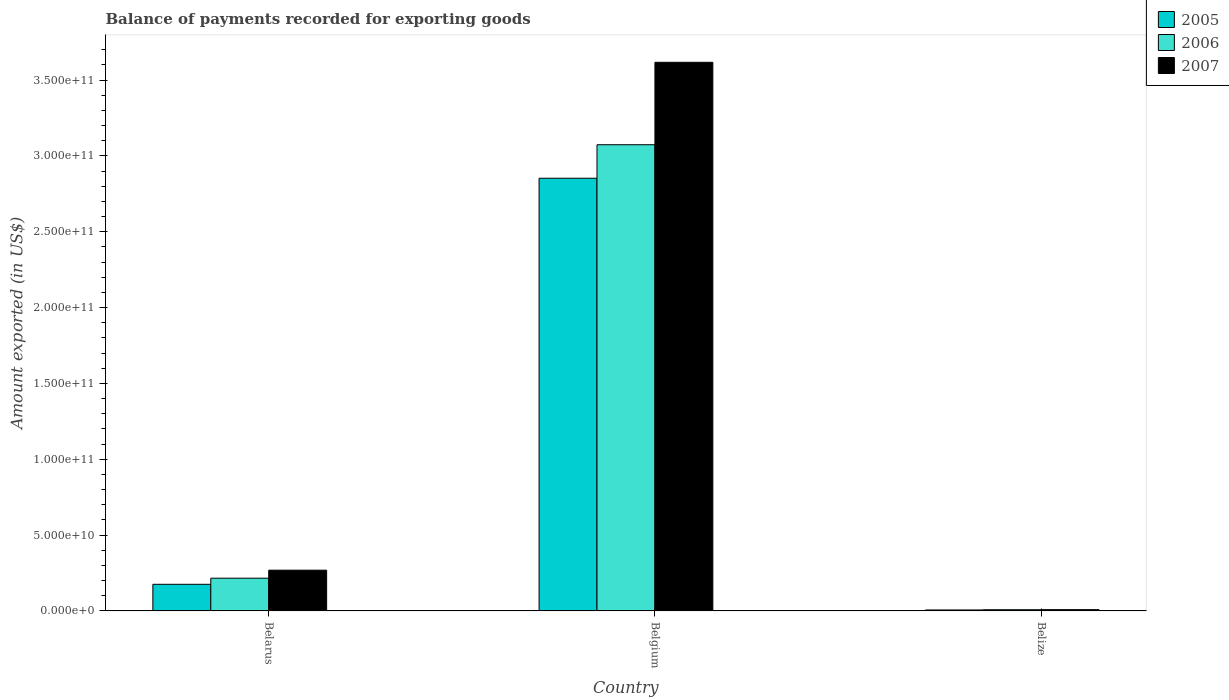How many different coloured bars are there?
Make the answer very short. 3. How many groups of bars are there?
Provide a short and direct response. 3. Are the number of bars on each tick of the X-axis equal?
Your response must be concise. Yes. What is the label of the 1st group of bars from the left?
Keep it short and to the point. Belarus. In how many cases, is the number of bars for a given country not equal to the number of legend labels?
Offer a terse response. 0. What is the amount exported in 2007 in Belgium?
Your response must be concise. 3.62e+11. Across all countries, what is the maximum amount exported in 2007?
Your answer should be very brief. 3.62e+11. Across all countries, what is the minimum amount exported in 2006?
Ensure brevity in your answer.  7.76e+08. In which country was the amount exported in 2007 minimum?
Provide a succinct answer. Belize. What is the total amount exported in 2006 in the graph?
Give a very brief answer. 3.30e+11. What is the difference between the amount exported in 2005 in Belarus and that in Belgium?
Your answer should be very brief. -2.68e+11. What is the difference between the amount exported in 2007 in Belgium and the amount exported in 2006 in Belarus?
Offer a very short reply. 3.40e+11. What is the average amount exported in 2005 per country?
Provide a succinct answer. 1.01e+11. What is the difference between the amount exported of/in 2006 and amount exported of/in 2007 in Belgium?
Make the answer very short. -5.44e+1. In how many countries, is the amount exported in 2007 greater than 180000000000 US$?
Ensure brevity in your answer.  1. What is the ratio of the amount exported in 2006 in Belarus to that in Belize?
Offer a very short reply. 27.8. What is the difference between the highest and the second highest amount exported in 2005?
Provide a succinct answer. 2.85e+11. What is the difference between the highest and the lowest amount exported in 2005?
Your response must be concise. 2.85e+11. What does the 1st bar from the left in Belize represents?
Your answer should be compact. 2005. What does the 3rd bar from the right in Belgium represents?
Your response must be concise. 2005. How many bars are there?
Keep it short and to the point. 9. Are all the bars in the graph horizontal?
Provide a short and direct response. No. What is the difference between two consecutive major ticks on the Y-axis?
Offer a very short reply. 5.00e+1. Does the graph contain grids?
Your response must be concise. No. Where does the legend appear in the graph?
Ensure brevity in your answer.  Top right. How are the legend labels stacked?
Your response must be concise. Vertical. What is the title of the graph?
Provide a succinct answer. Balance of payments recorded for exporting goods. What is the label or title of the X-axis?
Give a very brief answer. Country. What is the label or title of the Y-axis?
Offer a very short reply. Amount exported (in US$). What is the Amount exported (in US$) of 2005 in Belarus?
Your answer should be compact. 1.75e+1. What is the Amount exported (in US$) in 2006 in Belarus?
Offer a very short reply. 2.16e+1. What is the Amount exported (in US$) of 2007 in Belarus?
Keep it short and to the point. 2.69e+1. What is the Amount exported (in US$) in 2005 in Belgium?
Keep it short and to the point. 2.85e+11. What is the Amount exported (in US$) of 2006 in Belgium?
Offer a very short reply. 3.07e+11. What is the Amount exported (in US$) of 2007 in Belgium?
Offer a very short reply. 3.62e+11. What is the Amount exported (in US$) of 2005 in Belize?
Give a very brief answer. 6.15e+08. What is the Amount exported (in US$) in 2006 in Belize?
Your answer should be very brief. 7.76e+08. What is the Amount exported (in US$) of 2007 in Belize?
Keep it short and to the point. 8.16e+08. Across all countries, what is the maximum Amount exported (in US$) in 2005?
Offer a terse response. 2.85e+11. Across all countries, what is the maximum Amount exported (in US$) in 2006?
Ensure brevity in your answer.  3.07e+11. Across all countries, what is the maximum Amount exported (in US$) of 2007?
Your answer should be very brief. 3.62e+11. Across all countries, what is the minimum Amount exported (in US$) of 2005?
Make the answer very short. 6.15e+08. Across all countries, what is the minimum Amount exported (in US$) in 2006?
Provide a short and direct response. 7.76e+08. Across all countries, what is the minimum Amount exported (in US$) in 2007?
Your answer should be very brief. 8.16e+08. What is the total Amount exported (in US$) of 2005 in the graph?
Keep it short and to the point. 3.03e+11. What is the total Amount exported (in US$) of 2006 in the graph?
Give a very brief answer. 3.30e+11. What is the total Amount exported (in US$) in 2007 in the graph?
Your answer should be very brief. 3.89e+11. What is the difference between the Amount exported (in US$) in 2005 in Belarus and that in Belgium?
Your response must be concise. -2.68e+11. What is the difference between the Amount exported (in US$) of 2006 in Belarus and that in Belgium?
Your response must be concise. -2.86e+11. What is the difference between the Amount exported (in US$) of 2007 in Belarus and that in Belgium?
Make the answer very short. -3.35e+11. What is the difference between the Amount exported (in US$) in 2005 in Belarus and that in Belize?
Your response must be concise. 1.69e+1. What is the difference between the Amount exported (in US$) of 2006 in Belarus and that in Belize?
Your answer should be compact. 2.08e+1. What is the difference between the Amount exported (in US$) of 2007 in Belarus and that in Belize?
Offer a very short reply. 2.60e+1. What is the difference between the Amount exported (in US$) in 2005 in Belgium and that in Belize?
Offer a terse response. 2.85e+11. What is the difference between the Amount exported (in US$) of 2006 in Belgium and that in Belize?
Offer a terse response. 3.07e+11. What is the difference between the Amount exported (in US$) in 2007 in Belgium and that in Belize?
Make the answer very short. 3.61e+11. What is the difference between the Amount exported (in US$) of 2005 in Belarus and the Amount exported (in US$) of 2006 in Belgium?
Offer a very short reply. -2.90e+11. What is the difference between the Amount exported (in US$) in 2005 in Belarus and the Amount exported (in US$) in 2007 in Belgium?
Offer a terse response. -3.44e+11. What is the difference between the Amount exported (in US$) in 2006 in Belarus and the Amount exported (in US$) in 2007 in Belgium?
Ensure brevity in your answer.  -3.40e+11. What is the difference between the Amount exported (in US$) in 2005 in Belarus and the Amount exported (in US$) in 2006 in Belize?
Your response must be concise. 1.68e+1. What is the difference between the Amount exported (in US$) in 2005 in Belarus and the Amount exported (in US$) in 2007 in Belize?
Give a very brief answer. 1.67e+1. What is the difference between the Amount exported (in US$) of 2006 in Belarus and the Amount exported (in US$) of 2007 in Belize?
Give a very brief answer. 2.08e+1. What is the difference between the Amount exported (in US$) in 2005 in Belgium and the Amount exported (in US$) in 2006 in Belize?
Provide a succinct answer. 2.85e+11. What is the difference between the Amount exported (in US$) of 2005 in Belgium and the Amount exported (in US$) of 2007 in Belize?
Your answer should be compact. 2.85e+11. What is the difference between the Amount exported (in US$) in 2006 in Belgium and the Amount exported (in US$) in 2007 in Belize?
Offer a terse response. 3.07e+11. What is the average Amount exported (in US$) of 2005 per country?
Your answer should be very brief. 1.01e+11. What is the average Amount exported (in US$) in 2006 per country?
Your answer should be compact. 1.10e+11. What is the average Amount exported (in US$) of 2007 per country?
Provide a short and direct response. 1.30e+11. What is the difference between the Amount exported (in US$) in 2005 and Amount exported (in US$) in 2006 in Belarus?
Keep it short and to the point. -4.03e+09. What is the difference between the Amount exported (in US$) of 2005 and Amount exported (in US$) of 2007 in Belarus?
Make the answer very short. -9.32e+09. What is the difference between the Amount exported (in US$) in 2006 and Amount exported (in US$) in 2007 in Belarus?
Offer a terse response. -5.28e+09. What is the difference between the Amount exported (in US$) in 2005 and Amount exported (in US$) in 2006 in Belgium?
Keep it short and to the point. -2.21e+1. What is the difference between the Amount exported (in US$) in 2005 and Amount exported (in US$) in 2007 in Belgium?
Provide a succinct answer. -7.65e+1. What is the difference between the Amount exported (in US$) in 2006 and Amount exported (in US$) in 2007 in Belgium?
Provide a short and direct response. -5.44e+1. What is the difference between the Amount exported (in US$) of 2005 and Amount exported (in US$) of 2006 in Belize?
Your response must be concise. -1.61e+08. What is the difference between the Amount exported (in US$) in 2005 and Amount exported (in US$) in 2007 in Belize?
Your answer should be compact. -2.01e+08. What is the difference between the Amount exported (in US$) of 2006 and Amount exported (in US$) of 2007 in Belize?
Give a very brief answer. -4.04e+07. What is the ratio of the Amount exported (in US$) in 2005 in Belarus to that in Belgium?
Offer a terse response. 0.06. What is the ratio of the Amount exported (in US$) in 2006 in Belarus to that in Belgium?
Give a very brief answer. 0.07. What is the ratio of the Amount exported (in US$) of 2007 in Belarus to that in Belgium?
Keep it short and to the point. 0.07. What is the ratio of the Amount exported (in US$) of 2005 in Belarus to that in Belize?
Ensure brevity in your answer.  28.51. What is the ratio of the Amount exported (in US$) of 2006 in Belarus to that in Belize?
Make the answer very short. 27.8. What is the ratio of the Amount exported (in US$) of 2007 in Belarus to that in Belize?
Keep it short and to the point. 32.89. What is the ratio of the Amount exported (in US$) of 2005 in Belgium to that in Belize?
Offer a very short reply. 463.93. What is the ratio of the Amount exported (in US$) of 2006 in Belgium to that in Belize?
Your answer should be compact. 396.18. What is the ratio of the Amount exported (in US$) of 2007 in Belgium to that in Belize?
Provide a succinct answer. 443.16. What is the difference between the highest and the second highest Amount exported (in US$) in 2005?
Your answer should be compact. 2.68e+11. What is the difference between the highest and the second highest Amount exported (in US$) of 2006?
Give a very brief answer. 2.86e+11. What is the difference between the highest and the second highest Amount exported (in US$) of 2007?
Your response must be concise. 3.35e+11. What is the difference between the highest and the lowest Amount exported (in US$) of 2005?
Offer a very short reply. 2.85e+11. What is the difference between the highest and the lowest Amount exported (in US$) of 2006?
Your answer should be compact. 3.07e+11. What is the difference between the highest and the lowest Amount exported (in US$) in 2007?
Ensure brevity in your answer.  3.61e+11. 